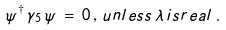<formula> <loc_0><loc_0><loc_500><loc_500>\psi ^ { \dagger } \, \gamma _ { 5 } \, \psi \, = \, 0 \, , \, u n l e s s \, \lambda \, i s r e a l \, .</formula> 